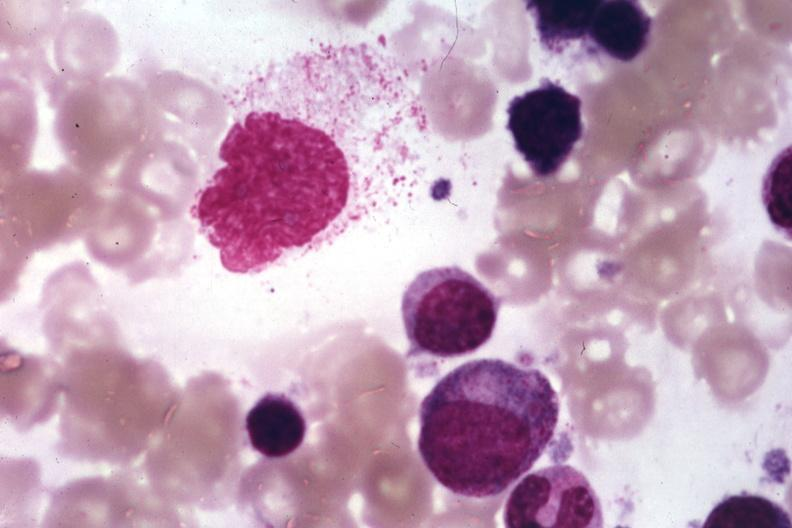what does this image show?
Answer the question using a single word or phrase. Wrights 